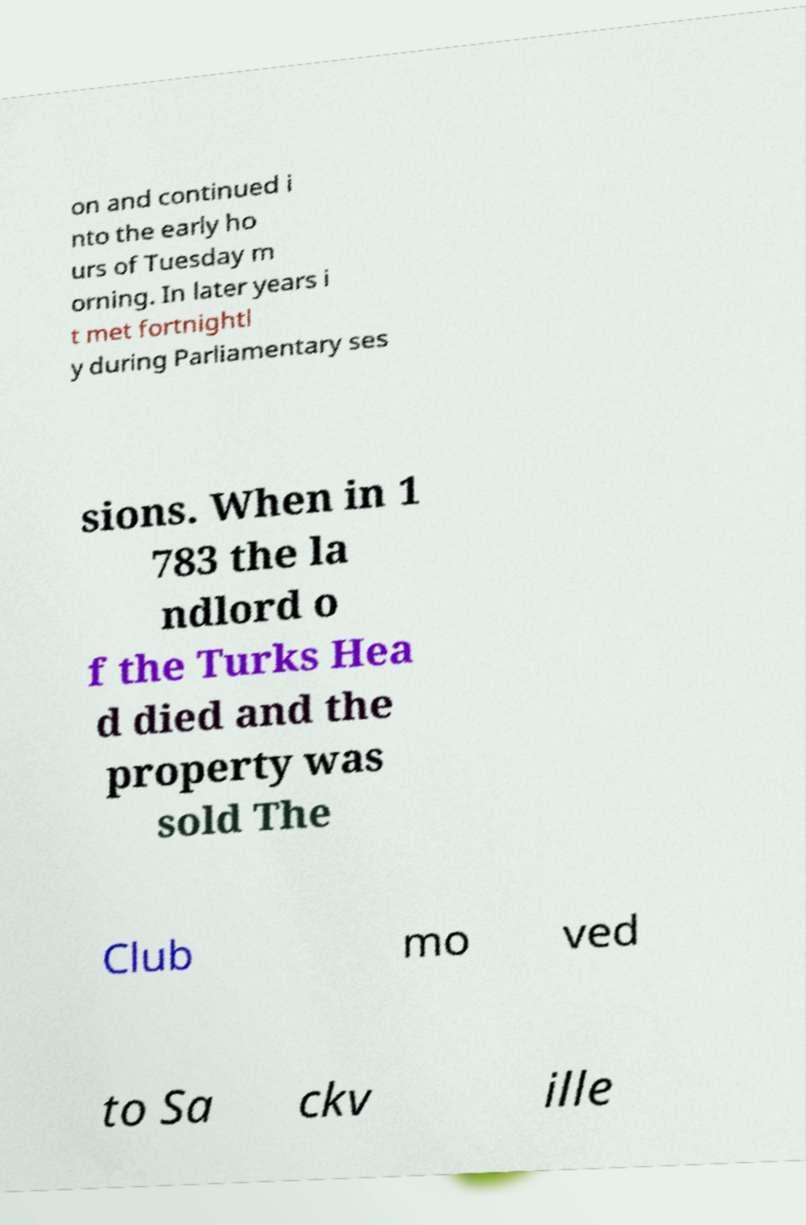For documentation purposes, I need the text within this image transcribed. Could you provide that? on and continued i nto the early ho urs of Tuesday m orning. In later years i t met fortnightl y during Parliamentary ses sions. When in 1 783 the la ndlord o f the Turks Hea d died and the property was sold The Club mo ved to Sa ckv ille 